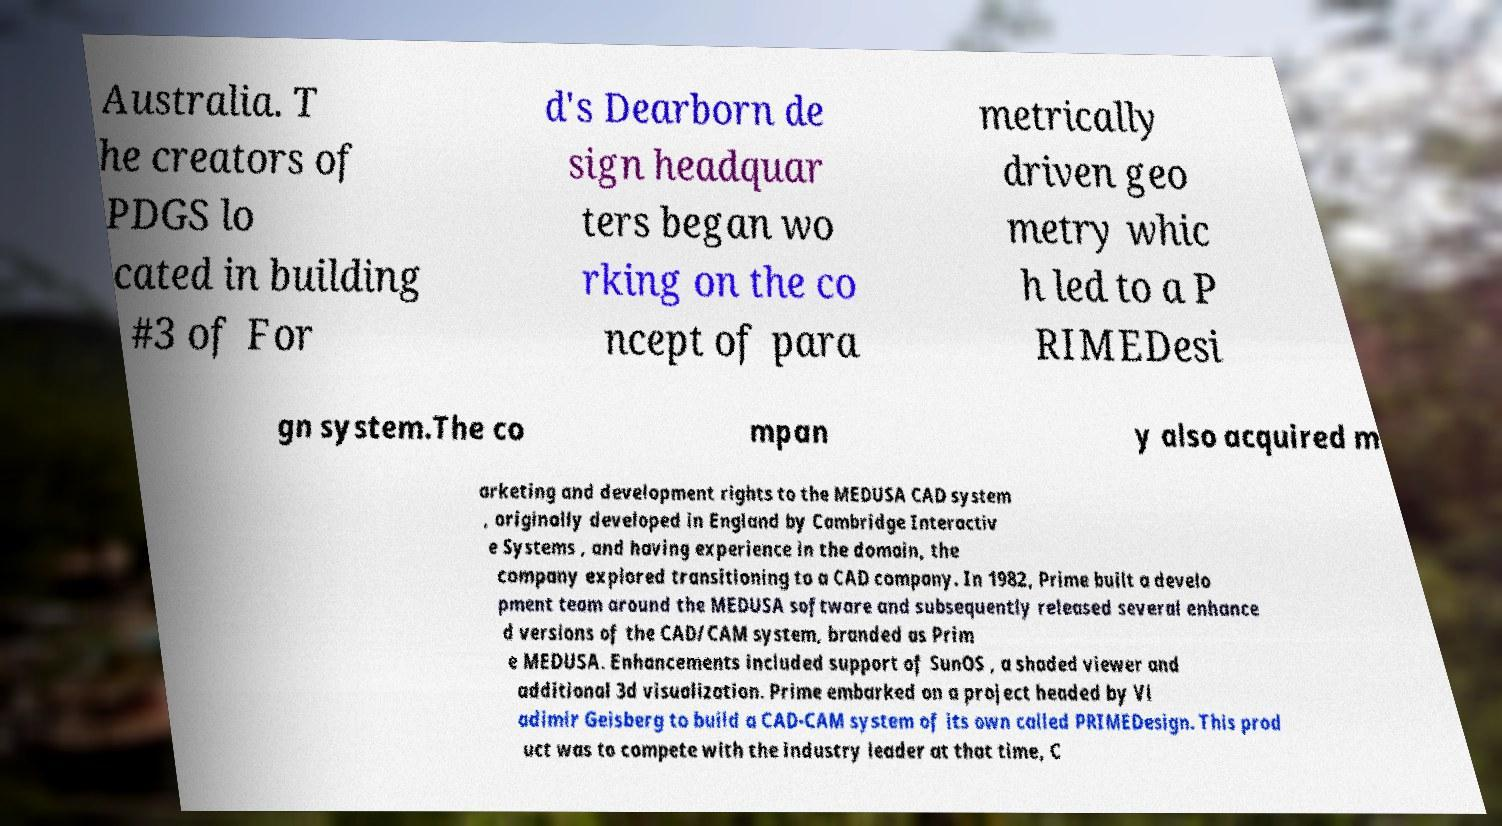For documentation purposes, I need the text within this image transcribed. Could you provide that? Australia. T he creators of PDGS lo cated in building #3 of For d's Dearborn de sign headquar ters began wo rking on the co ncept of para metrically driven geo metry whic h led to a P RIMEDesi gn system.The co mpan y also acquired m arketing and development rights to the MEDUSA CAD system , originally developed in England by Cambridge Interactiv e Systems , and having experience in the domain, the company explored transitioning to a CAD company. In 1982, Prime built a develo pment team around the MEDUSA software and subsequently released several enhance d versions of the CAD/CAM system, branded as Prim e MEDUSA. Enhancements included support of SunOS , a shaded viewer and additional 3d visualization. Prime embarked on a project headed by Vl adimir Geisberg to build a CAD-CAM system of its own called PRIMEDesign. This prod uct was to compete with the industry leader at that time, C 